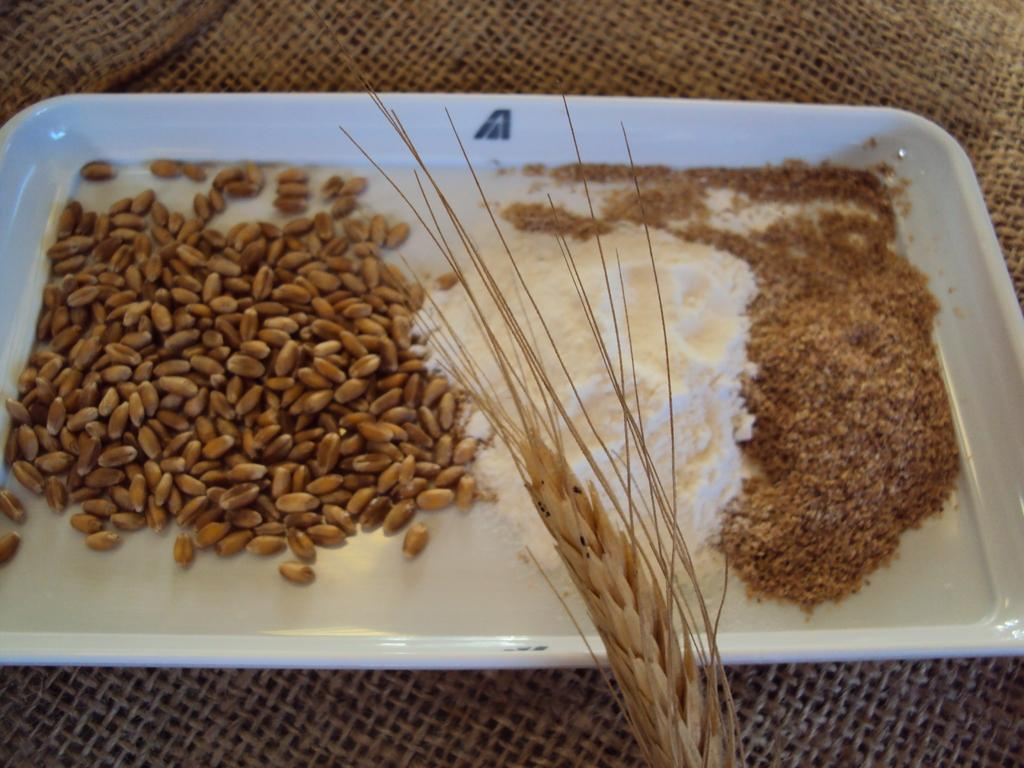What objects are present in the image? There are seeds in the image. What is the color of the tray containing the seeds? The tray is white. On what type of surface is the tray placed? The tray is placed on a mesh surface. How many frogs can be seen in the image? There are no frogs present in the image. In which room of a house might this image be taken? The image does not provide any information about the room or location where it was taken. 